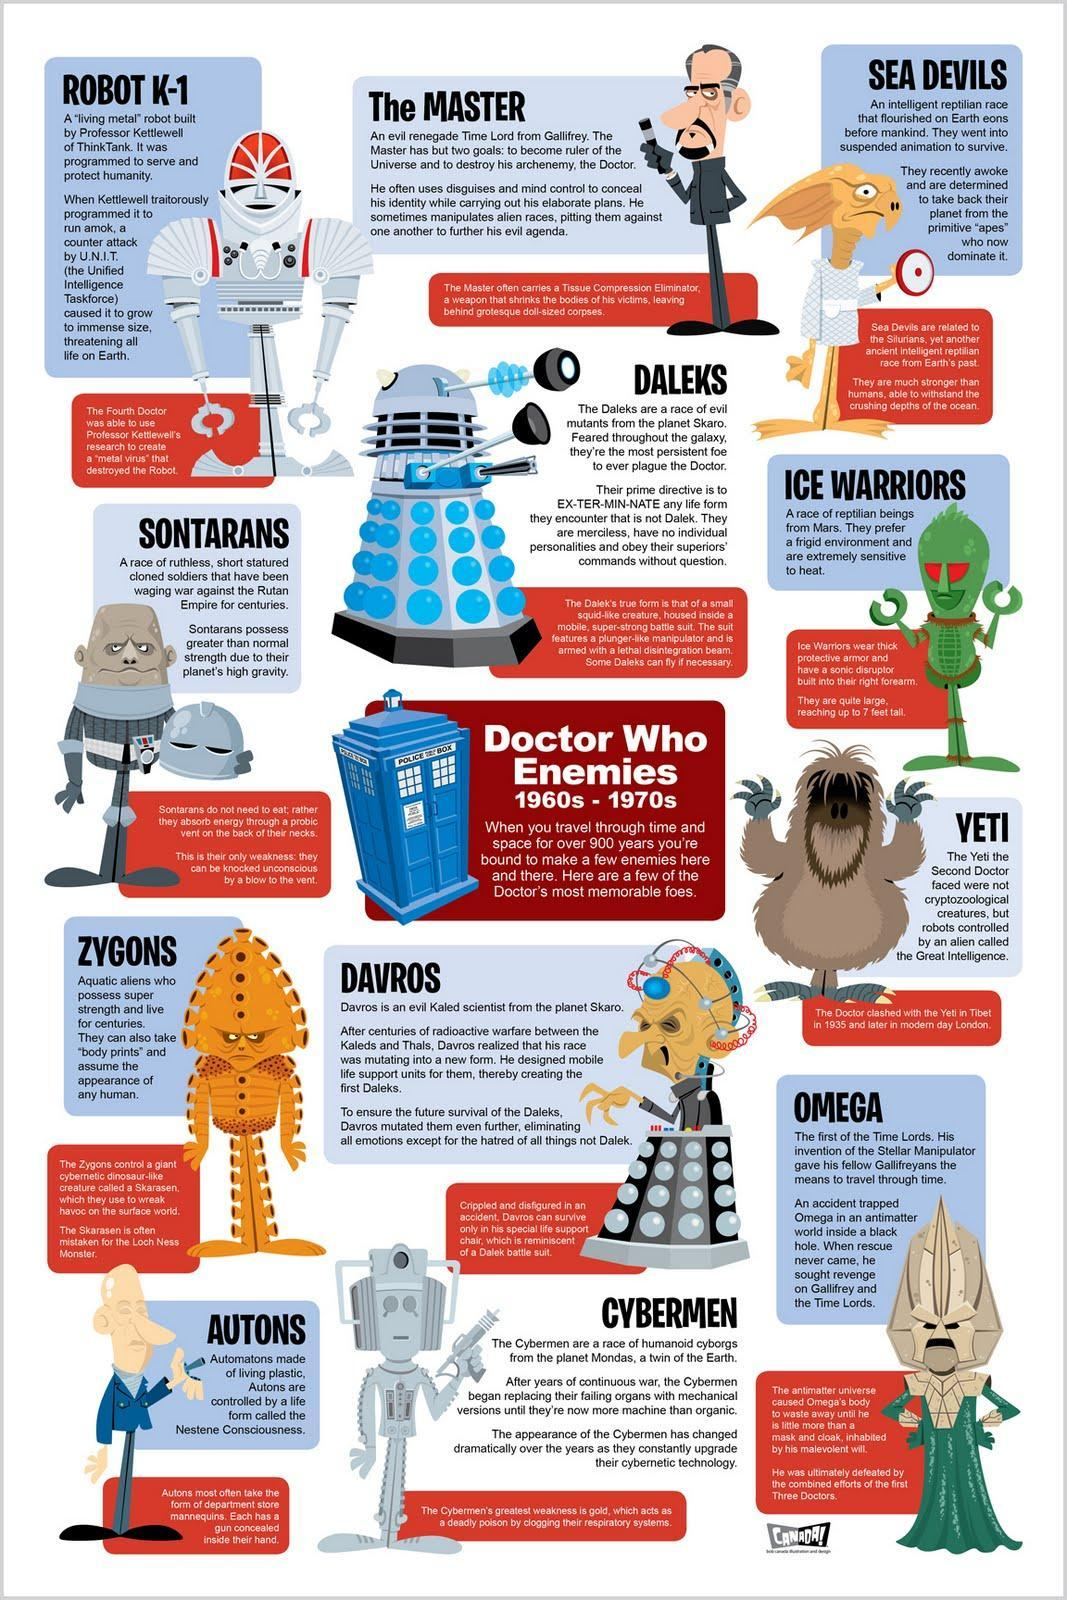who is often mistaken for the lock ness monster
Answer the question with a short phrase. the skarasen who is holding a helmet in his hand? sontarans how many enemies does the doctor have 12 who are extremely sensitive to heat ice warriors the enemies identified are in a period of how many years 10 what is the colour of the police box, blue, red? blue 